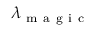Convert formula to latex. <formula><loc_0><loc_0><loc_500><loc_500>\lambda _ { m a g i c }</formula> 